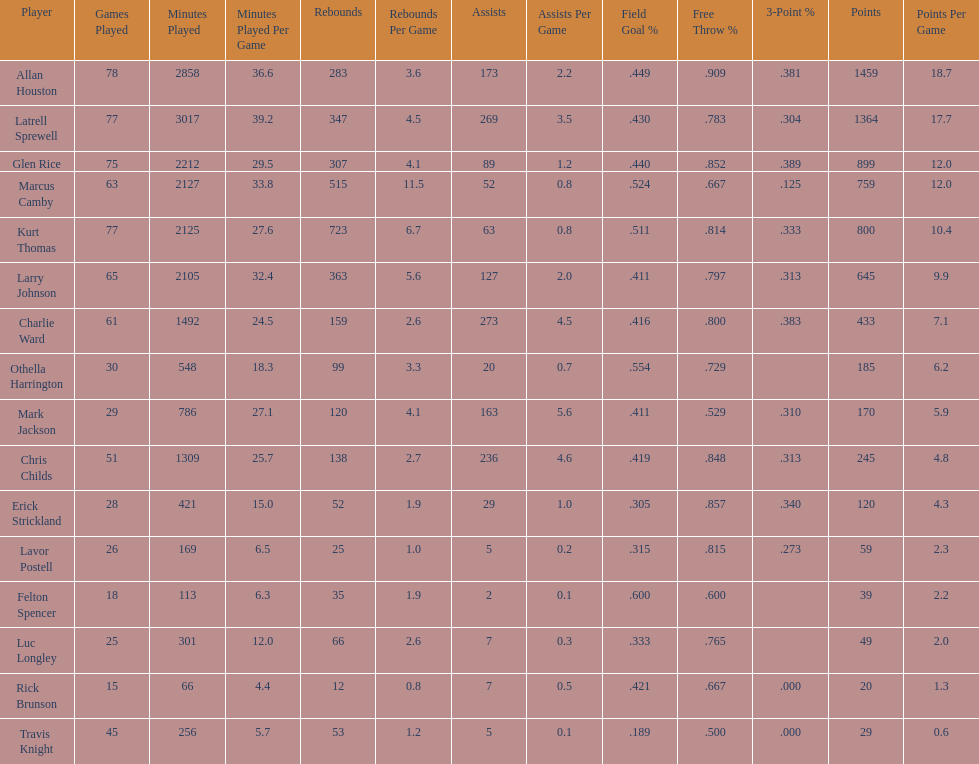Who scored more points, larry johnson or charlie ward? Larry Johnson. Would you be able to parse every entry in this table? {'header': ['Player', 'Games Played', 'Minutes Played', 'Minutes Played Per Game', 'Rebounds', 'Rebounds Per Game', 'Assists', 'Assists Per Game', 'Field Goal\xa0%', 'Free Throw\xa0%', '3-Point\xa0%', 'Points', 'Points Per Game'], 'rows': [['Allan Houston', '78', '2858', '36.6', '283', '3.6', '173', '2.2', '.449', '.909', '.381', '1459', '18.7'], ['Latrell Sprewell', '77', '3017', '39.2', '347', '4.5', '269', '3.5', '.430', '.783', '.304', '1364', '17.7'], ['Glen Rice', '75', '2212', '29.5', '307', '4.1', '89', '1.2', '.440', '.852', '.389', '899', '12.0'], ['Marcus Camby', '63', '2127', '33.8', '515', '11.5', '52', '0.8', '.524', '.667', '.125', '759', '12.0'], ['Kurt Thomas', '77', '2125', '27.6', '723', '6.7', '63', '0.8', '.511', '.814', '.333', '800', '10.4'], ['Larry Johnson', '65', '2105', '32.4', '363', '5.6', '127', '2.0', '.411', '.797', '.313', '645', '9.9'], ['Charlie Ward', '61', '1492', '24.5', '159', '2.6', '273', '4.5', '.416', '.800', '.383', '433', '7.1'], ['Othella Harrington', '30', '548', '18.3', '99', '3.3', '20', '0.7', '.554', '.729', '', '185', '6.2'], ['Mark Jackson', '29', '786', '27.1', '120', '4.1', '163', '5.6', '.411', '.529', '.310', '170', '5.9'], ['Chris Childs', '51', '1309', '25.7', '138', '2.7', '236', '4.6', '.419', '.848', '.313', '245', '4.8'], ['Erick Strickland', '28', '421', '15.0', '52', '1.9', '29', '1.0', '.305', '.857', '.340', '120', '4.3'], ['Lavor Postell', '26', '169', '6.5', '25', '1.0', '5', '0.2', '.315', '.815', '.273', '59', '2.3'], ['Felton Spencer', '18', '113', '6.3', '35', '1.9', '2', '0.1', '.600', '.600', '', '39', '2.2'], ['Luc Longley', '25', '301', '12.0', '66', '2.6', '7', '0.3', '.333', '.765', '', '49', '2.0'], ['Rick Brunson', '15', '66', '4.4', '12', '0.8', '7', '0.5', '.421', '.667', '.000', '20', '1.3'], ['Travis Knight', '45', '256', '5.7', '53', '1.2', '5', '0.1', '.189', '.500', '.000', '29', '0.6']]} 